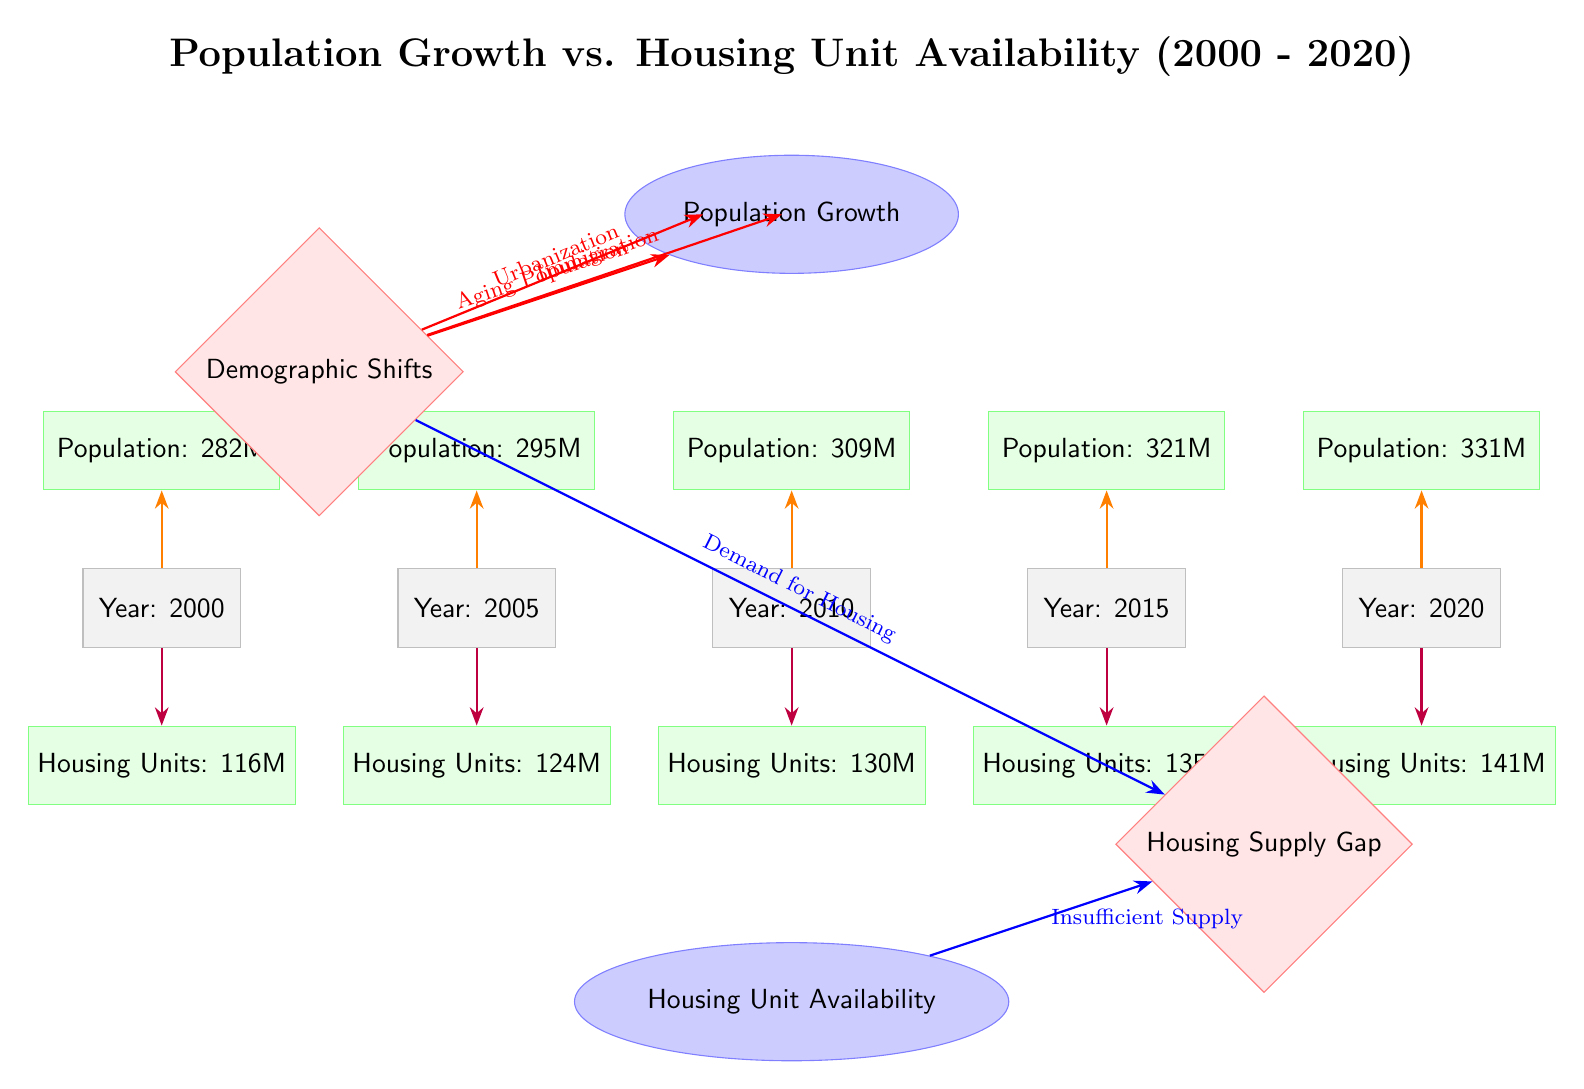What was the population in 2010? The diagram shows a data node under the year 2010 stating the population is 309 million.
Answer: 309M What is the housing unit availability in 2020? Referring to the data node for the year 2020, it indicates that the housing units available are 141 million.
Answer: 141M How many years does the diagram cover? The diagram displays years from 2000 to 2020, which gives us a total of 21 years when counting inclusively.
Answer: 21 years What factor is contributing to the demand for housing? The diagram has an arrow labeled "Demand for Housing" leading from the factor node "Demographic Shifts" to the housing supply gap.
Answer: Demographic Shifts What was the population growth from 2000 to 2020? The population increased from 282 million in 2000 to 331 million in 2020, which is a growth of 49 million.
Answer: 49M What does the orange arrow represent? The orange arrows in the diagram signify the relationship between each year and its corresponding population data.
Answer: Population data How do urbanization and immigration affect population growth? Both urbanization and immigration are factors of demographic shifts, leading to an increase in population growth towards the node labeled "Population Growth."
Answer: Increase in Population Growth Is there a housing supply gap at the end of the timeline? The diagram shows an arrow from "Insufficient Supply" under housing unit availability leading to the housing supply gap, indicating a shortage.
Answer: Yes What was the increase in housing units from 2005 to 2010? From 2005 with 124 million housing units to 2010 with 130 million units, the increase is 6 million units.
Answer: 6M 